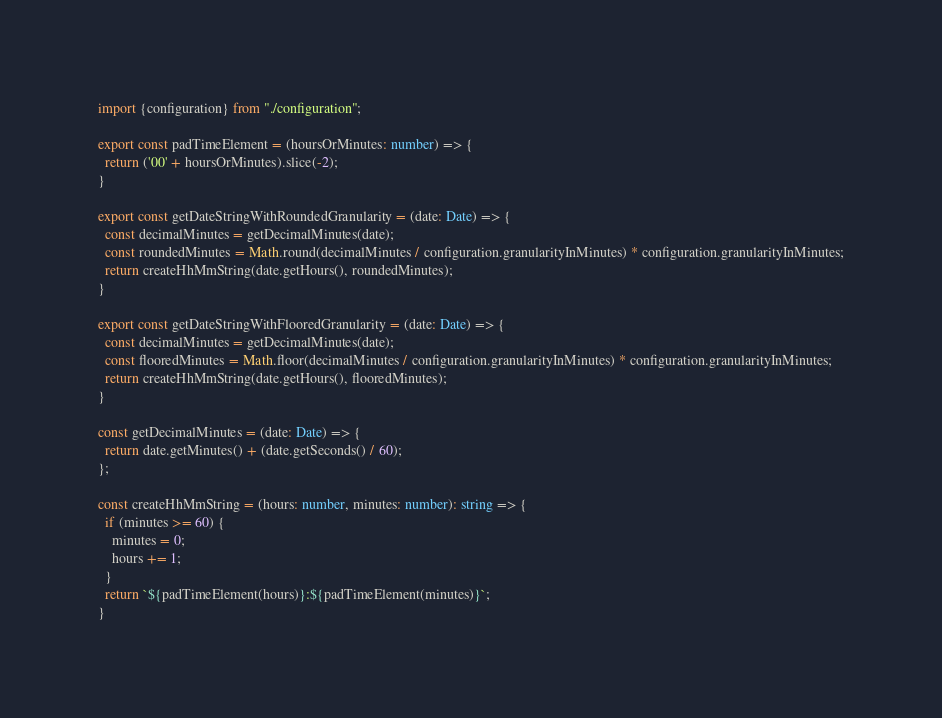<code> <loc_0><loc_0><loc_500><loc_500><_TypeScript_>import {configuration} from "./configuration";

export const padTimeElement = (hoursOrMinutes: number) => {
  return ('00' + hoursOrMinutes).slice(-2);
}

export const getDateStringWithRoundedGranularity = (date: Date) => {
  const decimalMinutes = getDecimalMinutes(date);
  const roundedMinutes = Math.round(decimalMinutes / configuration.granularityInMinutes) * configuration.granularityInMinutes;
  return createHhMmString(date.getHours(), roundedMinutes);
}

export const getDateStringWithFlooredGranularity = (date: Date) => {
  const decimalMinutes = getDecimalMinutes(date);
  const flooredMinutes = Math.floor(decimalMinutes / configuration.granularityInMinutes) * configuration.granularityInMinutes;
  return createHhMmString(date.getHours(), flooredMinutes);
}

const getDecimalMinutes = (date: Date) => {
  return date.getMinutes() + (date.getSeconds() / 60);
};

const createHhMmString = (hours: number, minutes: number): string => {
  if (minutes >= 60) {
    minutes = 0;
    hours += 1;
  }
  return `${padTimeElement(hours)}:${padTimeElement(minutes)}`;
}
</code> 